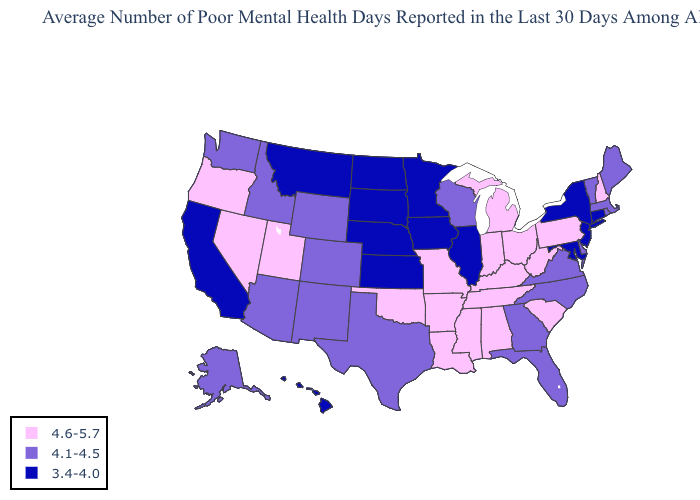What is the value of Utah?
Write a very short answer. 4.6-5.7. Which states have the lowest value in the USA?
Give a very brief answer. California, Connecticut, Hawaii, Illinois, Iowa, Kansas, Maryland, Minnesota, Montana, Nebraska, New Jersey, New York, North Dakota, South Dakota. Does Massachusetts have the highest value in the USA?
Quick response, please. No. Which states have the lowest value in the USA?
Quick response, please. California, Connecticut, Hawaii, Illinois, Iowa, Kansas, Maryland, Minnesota, Montana, Nebraska, New Jersey, New York, North Dakota, South Dakota. Does Kansas have the lowest value in the USA?
Write a very short answer. Yes. What is the value of New York?
Short answer required. 3.4-4.0. Name the states that have a value in the range 3.4-4.0?
Short answer required. California, Connecticut, Hawaii, Illinois, Iowa, Kansas, Maryland, Minnesota, Montana, Nebraska, New Jersey, New York, North Dakota, South Dakota. What is the highest value in the MidWest ?
Write a very short answer. 4.6-5.7. Name the states that have a value in the range 4.6-5.7?
Keep it brief. Alabama, Arkansas, Indiana, Kentucky, Louisiana, Michigan, Mississippi, Missouri, Nevada, New Hampshire, Ohio, Oklahoma, Oregon, Pennsylvania, South Carolina, Tennessee, Utah, West Virginia. Does the map have missing data?
Write a very short answer. No. Does Wisconsin have the lowest value in the MidWest?
Be succinct. No. What is the highest value in the South ?
Give a very brief answer. 4.6-5.7. What is the highest value in the USA?
Give a very brief answer. 4.6-5.7. Does Kentucky have the lowest value in the South?
Give a very brief answer. No. Among the states that border Pennsylvania , does New Jersey have the highest value?
Be succinct. No. 